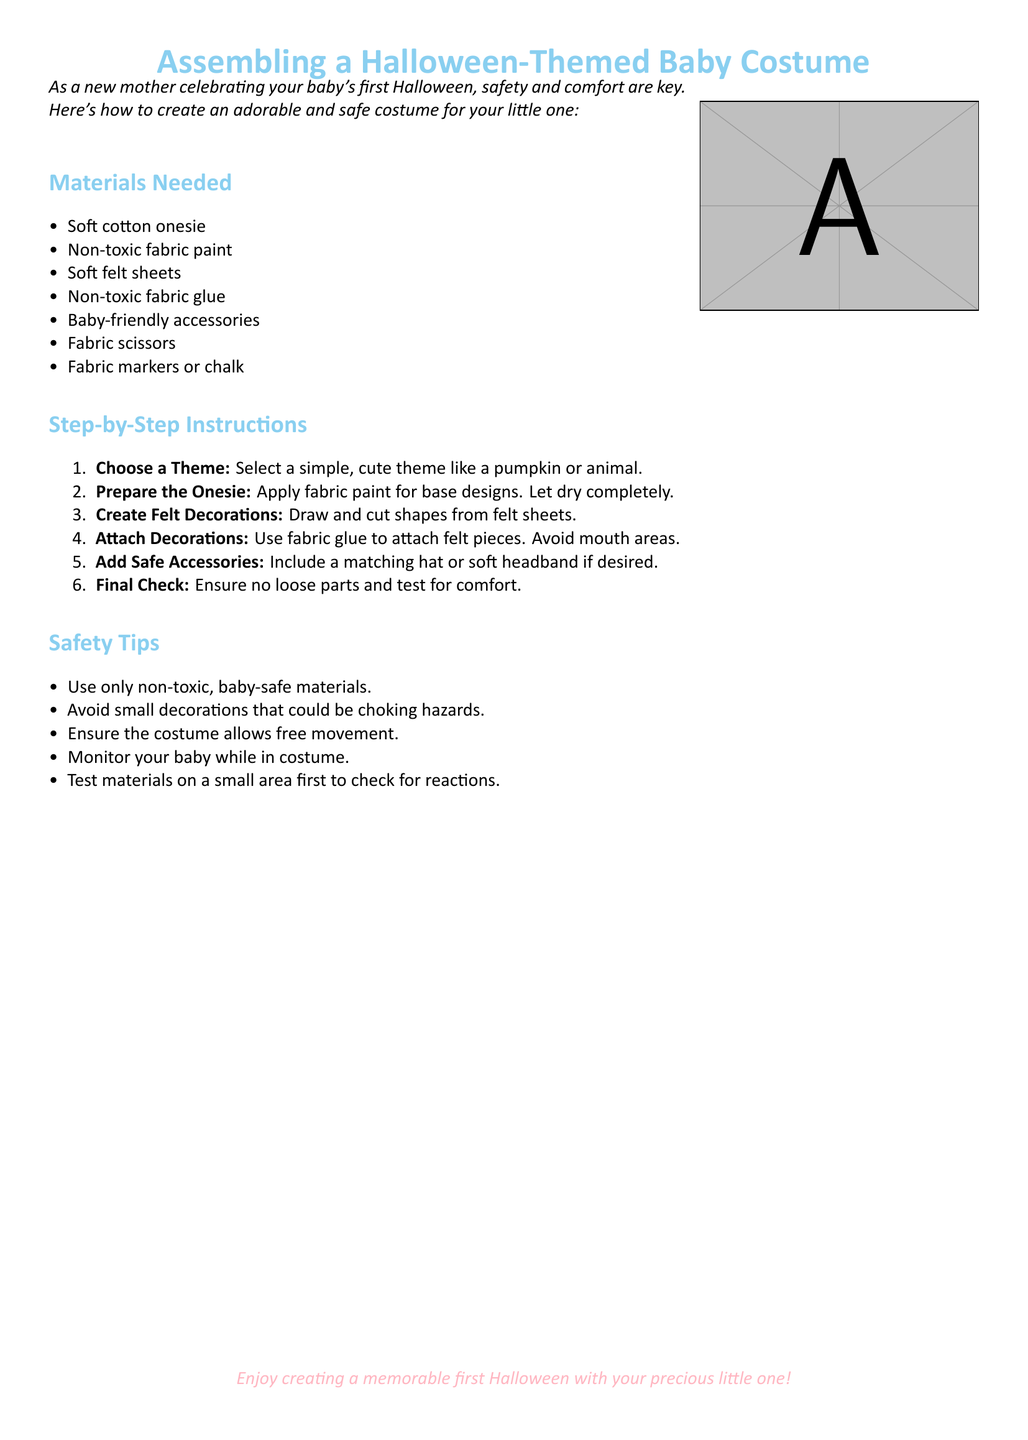what is the title of the document? The title is found at the beginning of the document, which is "Assembling a Halloween-Themed Baby Costume."
Answer: Assembling a Halloween-Themed Baby Costume how many materials are needed? The materials list contains six different items.
Answer: 6 what is the first item in the materials list? The first item listed under materials is a "Soft cotton onesie."
Answer: Soft cotton onesie what should you avoid when attaching decorations? The instructions specify to avoid mouth areas when attaching decorations.
Answer: Mouth areas which fabric type is used for decorations? The document states that soft felt sheets are used for decorations.
Answer: Felt sheets what is the theme suggested for the costume? The document suggests simple, cute themes like a pumpkin or animal.
Answer: Pumpkin or animal what is an essential safety tip mentioned? A crucial safety tip is to use only non-toxic, baby-safe materials.
Answer: Non-toxic, baby-safe materials what should you do after creating the costume? After creating the costume, you should perform a final check to ensure no loose parts and test for comfort.
Answer: Final check how should you monitor your baby? The document advises to monitor your baby while in costume.
Answer: Monitor your baby 